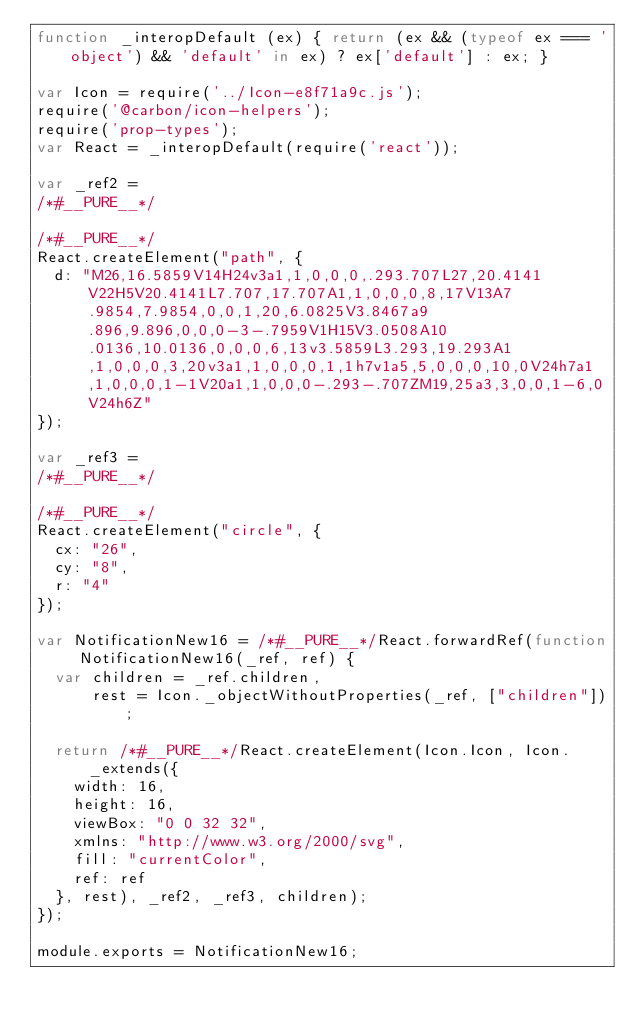<code> <loc_0><loc_0><loc_500><loc_500><_JavaScript_>function _interopDefault (ex) { return (ex && (typeof ex === 'object') && 'default' in ex) ? ex['default'] : ex; }

var Icon = require('../Icon-e8f71a9c.js');
require('@carbon/icon-helpers');
require('prop-types');
var React = _interopDefault(require('react'));

var _ref2 =
/*#__PURE__*/

/*#__PURE__*/
React.createElement("path", {
  d: "M26,16.5859V14H24v3a1,1,0,0,0,.293.707L27,20.4141V22H5V20.4141L7.707,17.707A1,1,0,0,0,8,17V13A7.9854,7.9854,0,0,1,20,6.0825V3.8467a9.896,9.896,0,0,0-3-.7959V1H15V3.0508A10.0136,10.0136,0,0,0,6,13v3.5859L3.293,19.293A1,1,0,0,0,3,20v3a1,1,0,0,0,1,1h7v1a5,5,0,0,0,10,0V24h7a1,1,0,0,0,1-1V20a1,1,0,0,0-.293-.707ZM19,25a3,3,0,0,1-6,0V24h6Z"
});

var _ref3 =
/*#__PURE__*/

/*#__PURE__*/
React.createElement("circle", {
  cx: "26",
  cy: "8",
  r: "4"
});

var NotificationNew16 = /*#__PURE__*/React.forwardRef(function NotificationNew16(_ref, ref) {
  var children = _ref.children,
      rest = Icon._objectWithoutProperties(_ref, ["children"]);

  return /*#__PURE__*/React.createElement(Icon.Icon, Icon._extends({
    width: 16,
    height: 16,
    viewBox: "0 0 32 32",
    xmlns: "http://www.w3.org/2000/svg",
    fill: "currentColor",
    ref: ref
  }, rest), _ref2, _ref3, children);
});

module.exports = NotificationNew16;
</code> 